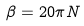<formula> <loc_0><loc_0><loc_500><loc_500>\beta = 2 0 \pi N</formula> 